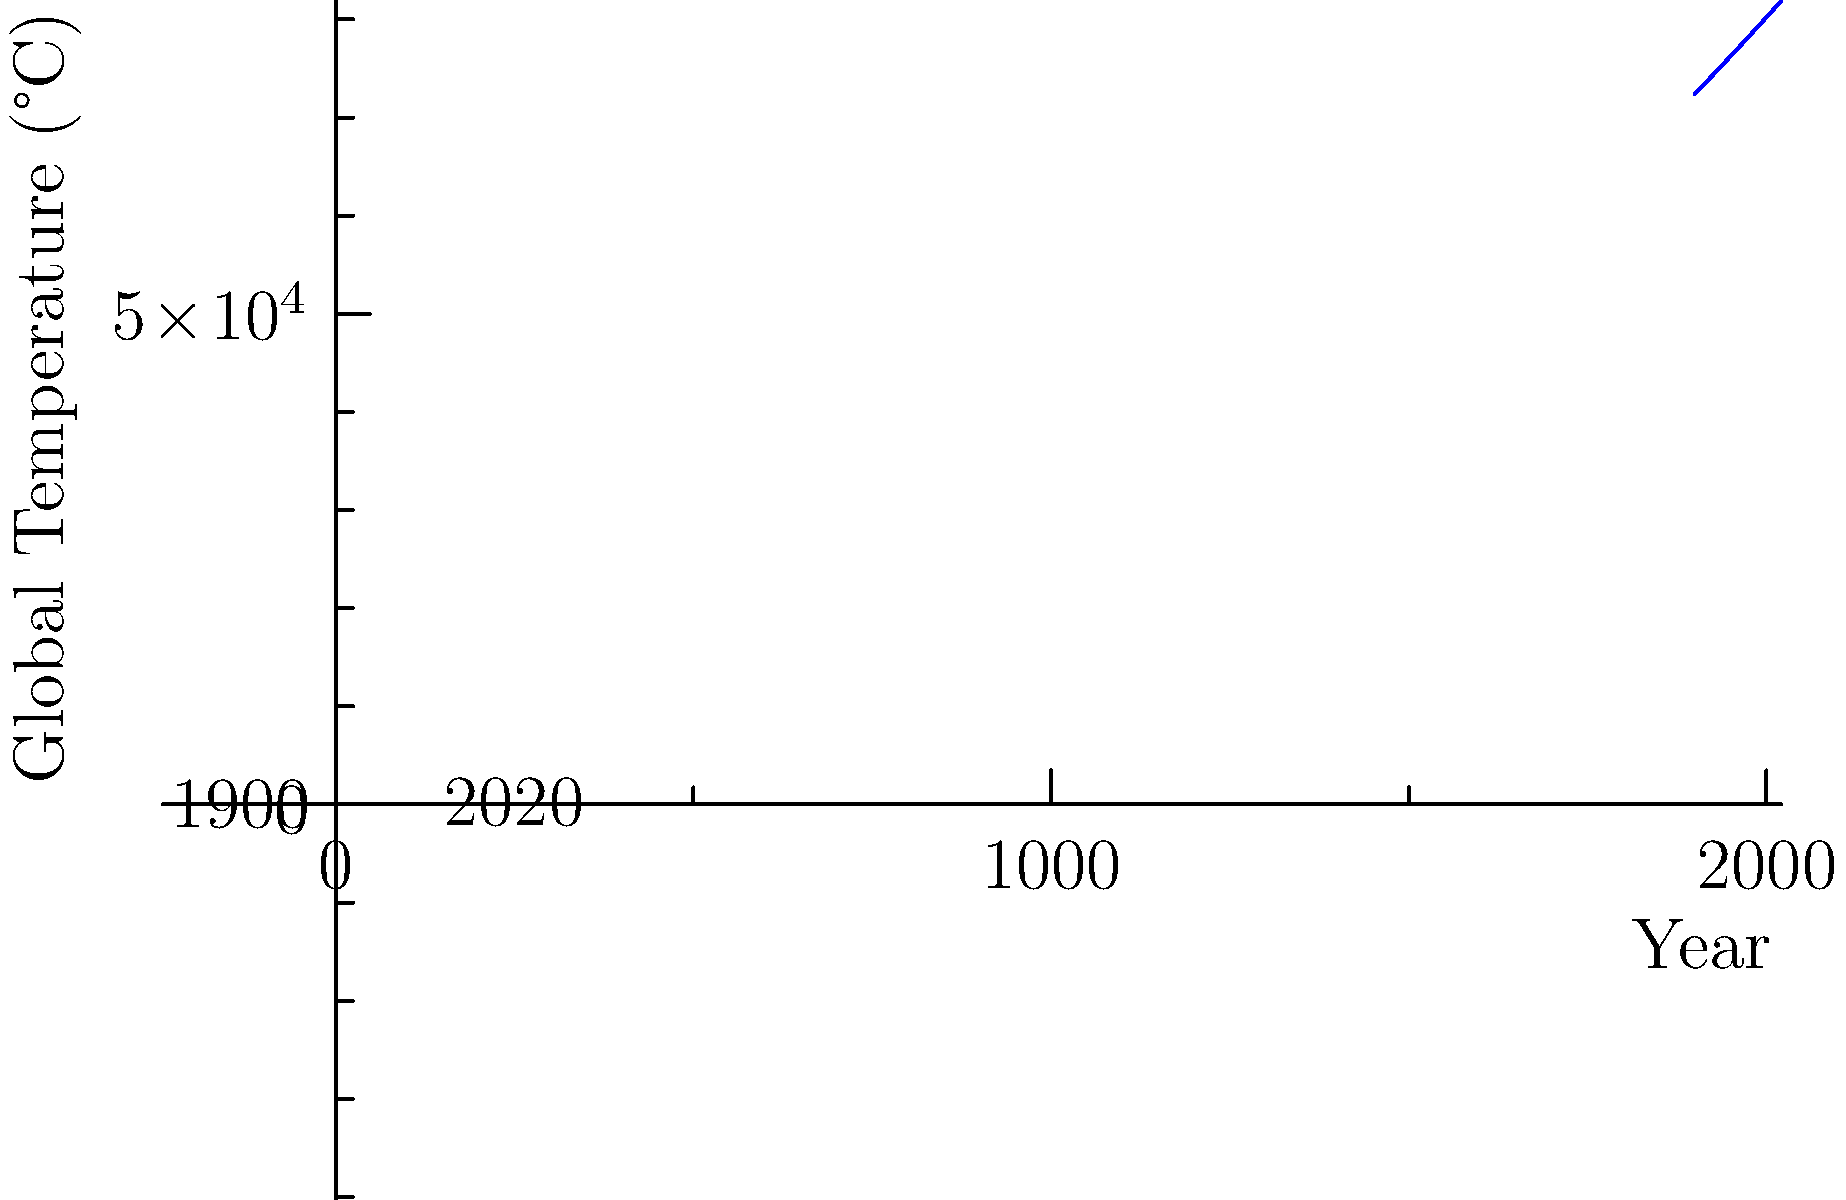Based on the trend shown in the global temperature rise graph, what is the projected increase in global temperature by 2050 compared to 1900 levels, assuming the current trend continues? To answer this question, we need to follow these steps:

1. Observe the trend: The graph shows an accelerating increase in global temperature from 1900 to 2020.

2. Identify key points:
   - In 1900 (x=0), the temperature is about 14°C
   - In 2020 (x=120), the temperature is approximately 17.5°C

3. Calculate the total increase from 1900 to 2020:
   $17.5°C - 14°C = 3.5°C$ over 120 years

4. Calculate the average rate of increase:
   $3.5°C / 120 years ≈ 0.029°C$ per year

5. Extrapolate to 2050:
   - Time from 2020 to 2050: 30 years
   - Additional increase: $30 * 0.029°C ≈ 0.87°C$

6. Estimate 2050 temperature:
   $17.5°C + 0.87°C ≈ 18.37°C$

7. Calculate total increase from 1900 to 2050:
   $18.37°C - 14°C ≈ 4.37°C$

Note: This is a simplified linear extrapolation. The actual trend appears to be accelerating, so this estimate is likely conservative.
Answer: Approximately 4.4°C increase by 2050 compared to 1900 levels. 